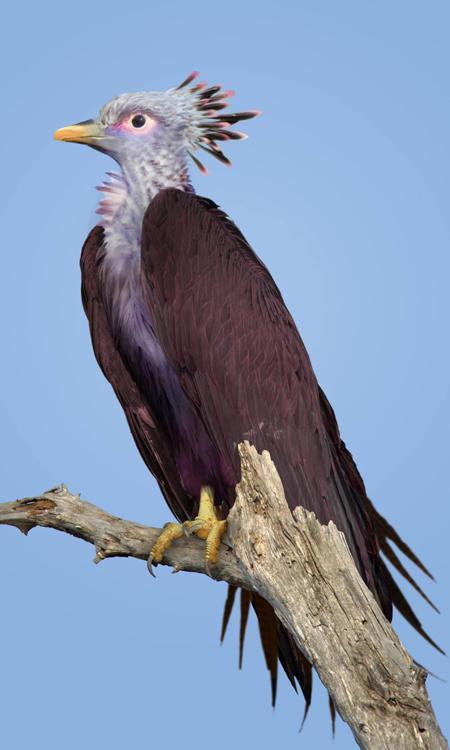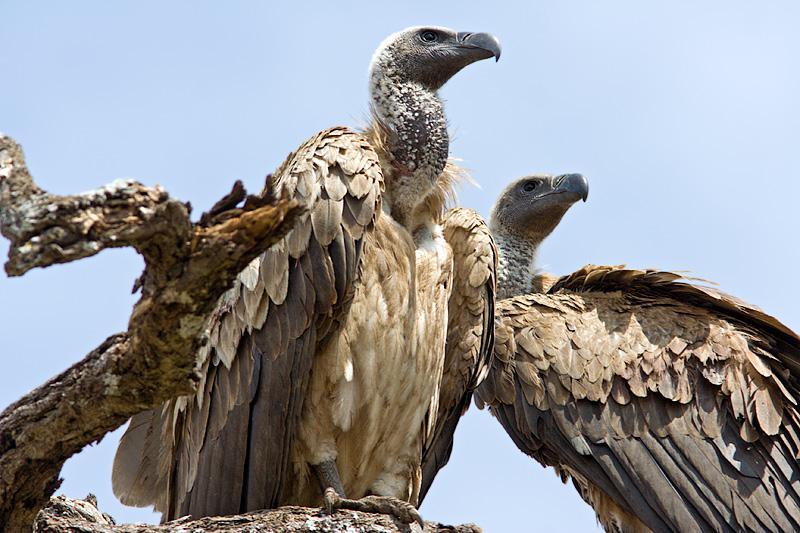The first image is the image on the left, the second image is the image on the right. Analyze the images presented: Is the assertion "There is at least one bird sitting on a branch in each picture." valid? Answer yes or no. Yes. 